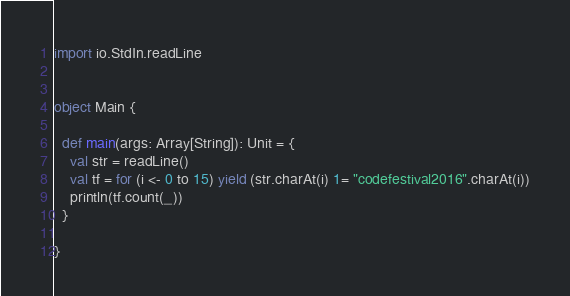Convert code to text. <code><loc_0><loc_0><loc_500><loc_500><_Scala_>import io.StdIn.readLine


object Main {

  def main(args: Array[String]): Unit = {
    val str = readLine()
    val tf = for (i <- 0 to 15) yield (str.charAt(i) 1= "codefestival2016".charAt(i))
    println(tf.count(_))
  }

}
</code> 